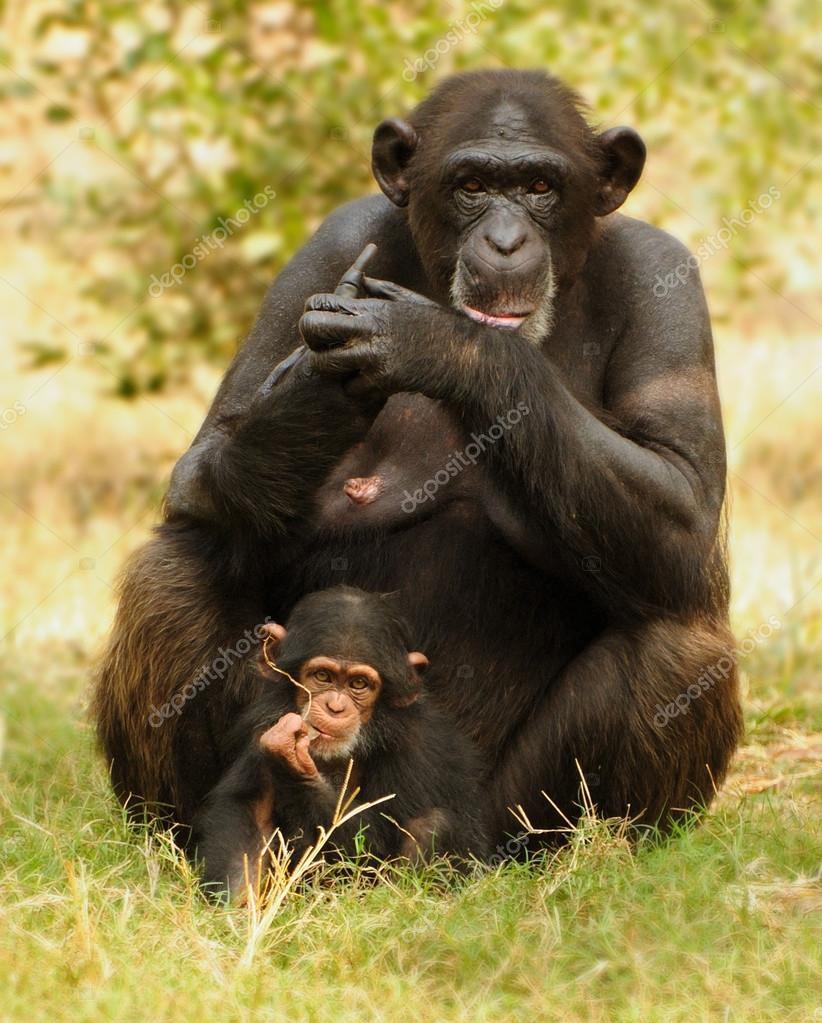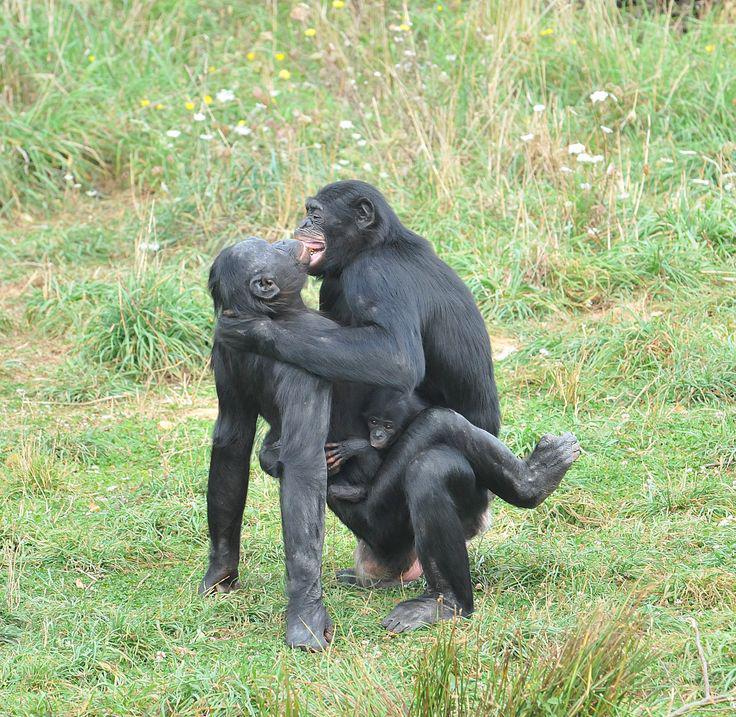The first image is the image on the left, the second image is the image on the right. Given the left and right images, does the statement "An image shows just one baby chimp riding on its mother's back." hold true? Answer yes or no. No. 